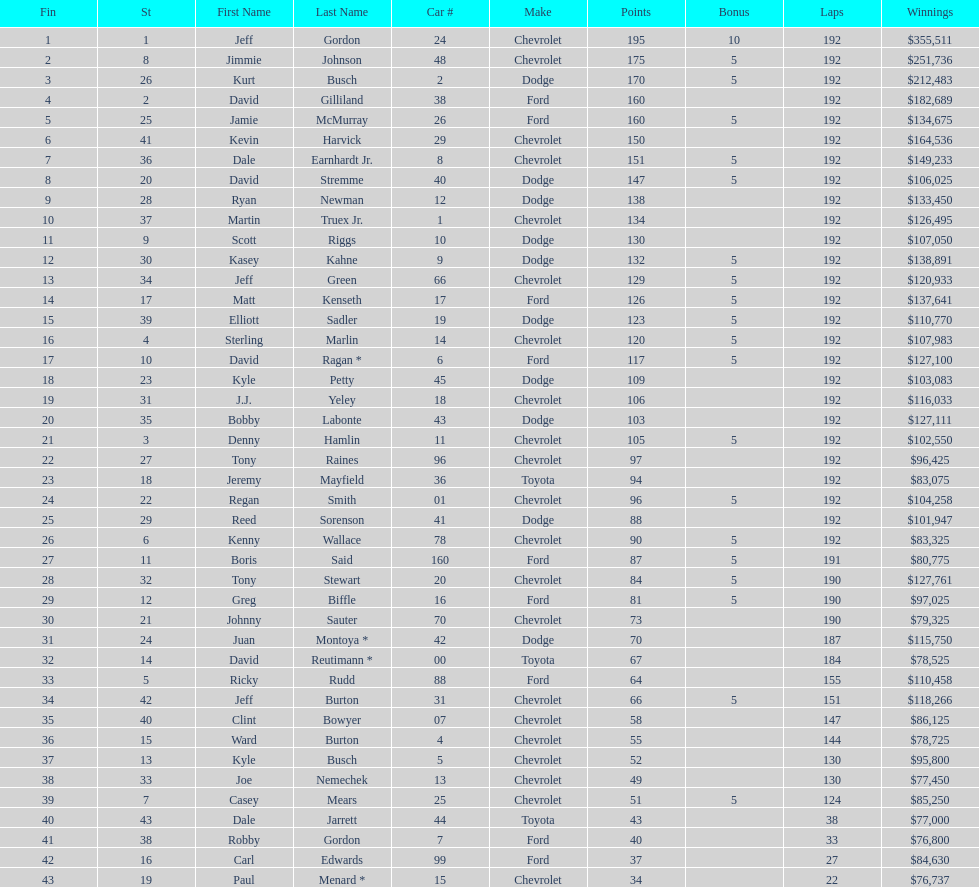What was the make of both jeff gordon's and jimmie johnson's race car? Chevrolet. 